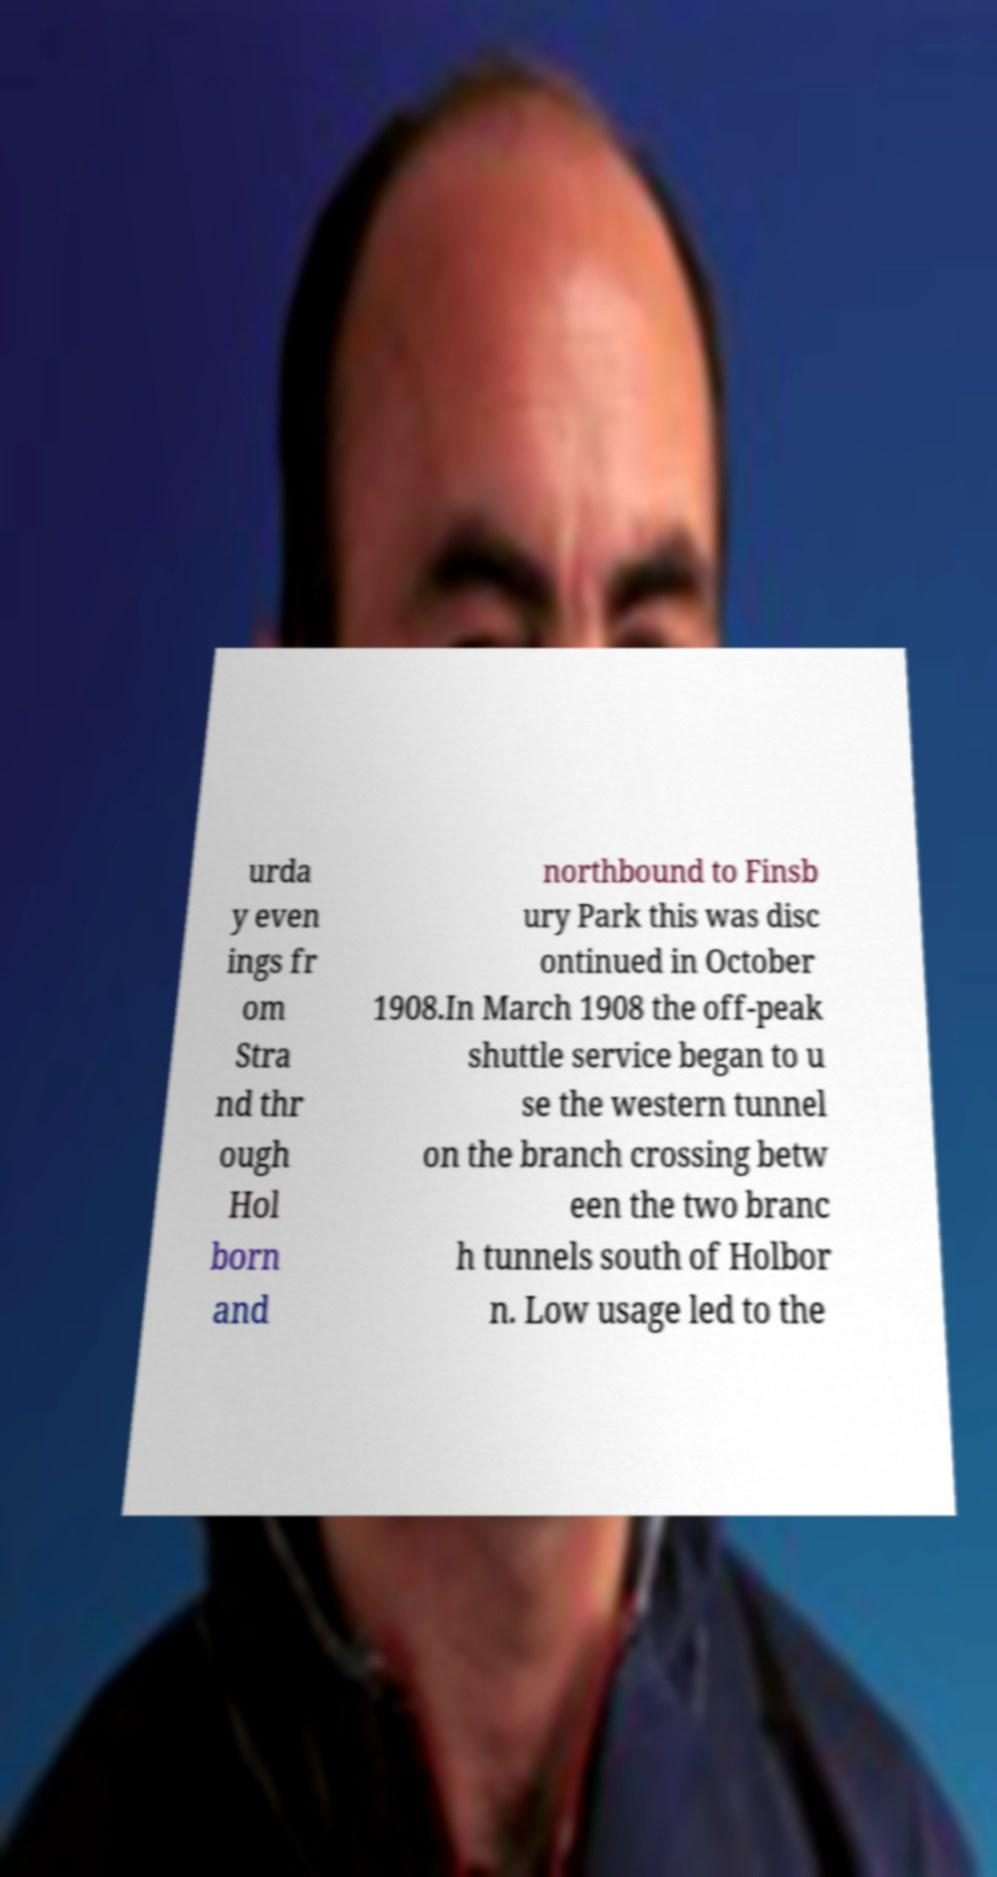For documentation purposes, I need the text within this image transcribed. Could you provide that? urda y even ings fr om Stra nd thr ough Hol born and northbound to Finsb ury Park this was disc ontinued in October 1908.In March 1908 the off-peak shuttle service began to u se the western tunnel on the branch crossing betw een the two branc h tunnels south of Holbor n. Low usage led to the 